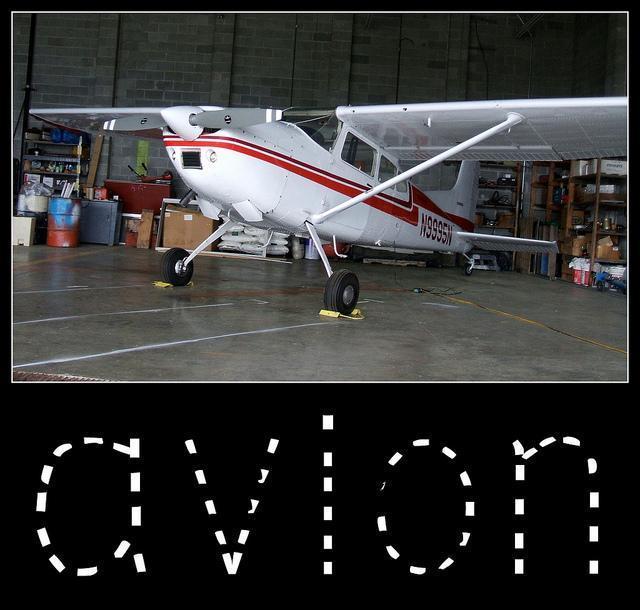How many wheels are there?
Give a very brief answer. 3. 